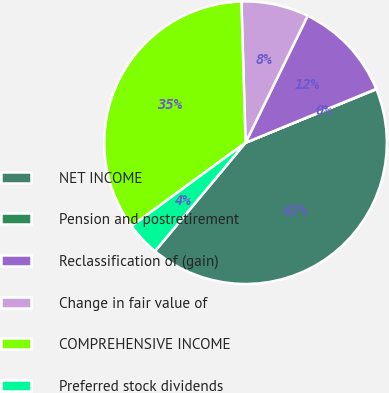<chart> <loc_0><loc_0><loc_500><loc_500><pie_chart><fcel>NET INCOME<fcel>Pension and postretirement<fcel>Reclassification of (gain)<fcel>Change in fair value of<fcel>COMPREHENSIVE INCOME<fcel>Preferred stock dividends<nl><fcel>42.25%<fcel>0.04%<fcel>11.54%<fcel>7.71%<fcel>34.59%<fcel>3.87%<nl></chart> 